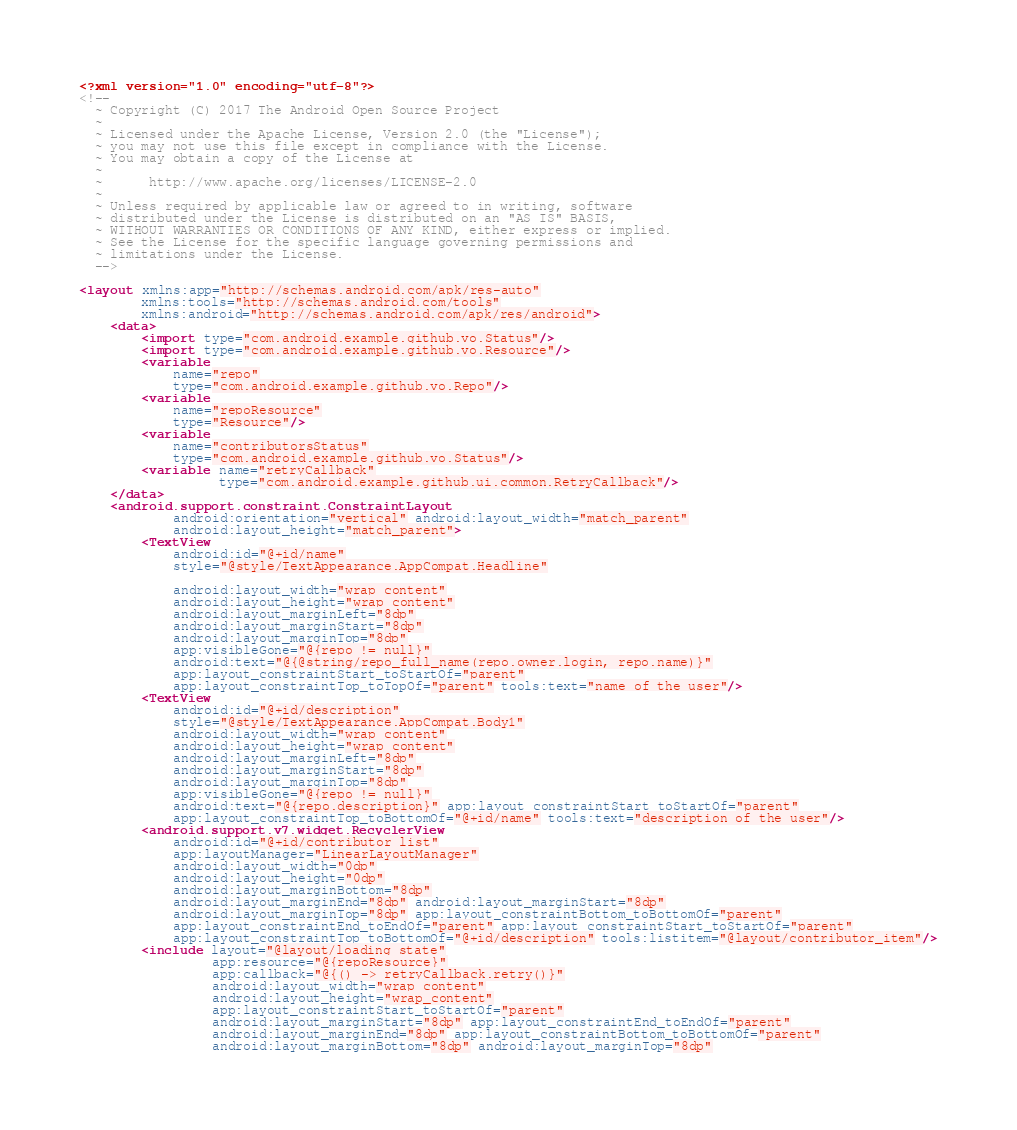Convert code to text. <code><loc_0><loc_0><loc_500><loc_500><_XML_><?xml version="1.0" encoding="utf-8"?>
<!--
  ~ Copyright (C) 2017 The Android Open Source Project
  ~
  ~ Licensed under the Apache License, Version 2.0 (the "License");
  ~ you may not use this file except in compliance with the License.
  ~ You may obtain a copy of the License at
  ~
  ~      http://www.apache.org/licenses/LICENSE-2.0
  ~
  ~ Unless required by applicable law or agreed to in writing, software
  ~ distributed under the License is distributed on an "AS IS" BASIS,
  ~ WITHOUT WARRANTIES OR CONDITIONS OF ANY KIND, either express or implied.
  ~ See the License for the specific language governing permissions and
  ~ limitations under the License.
  -->

<layout xmlns:app="http://schemas.android.com/apk/res-auto"
        xmlns:tools="http://schemas.android.com/tools"
        xmlns:android="http://schemas.android.com/apk/res/android">
    <data>
        <import type="com.android.example.github.vo.Status"/>
        <import type="com.android.example.github.vo.Resource"/>
        <variable
            name="repo"
            type="com.android.example.github.vo.Repo"/>
        <variable
            name="repoResource"
            type="Resource"/>
        <variable
            name="contributorsStatus"
            type="com.android.example.github.vo.Status"/>
        <variable name="retryCallback"
                  type="com.android.example.github.ui.common.RetryCallback"/>
    </data>
    <android.support.constraint.ConstraintLayout
            android:orientation="vertical" android:layout_width="match_parent"
            android:layout_height="match_parent">
        <TextView
            android:id="@+id/name"
            style="@style/TextAppearance.AppCompat.Headline"

            android:layout_width="wrap_content"
            android:layout_height="wrap_content"
            android:layout_marginLeft="8dp"
            android:layout_marginStart="8dp"
            android:layout_marginTop="8dp"
            app:visibleGone="@{repo != null}"
            android:text="@{@string/repo_full_name(repo.owner.login, repo.name)}"
            app:layout_constraintStart_toStartOf="parent"
            app:layout_constraintTop_toTopOf="parent" tools:text="name of the user"/>
        <TextView
            android:id="@+id/description"
            style="@style/TextAppearance.AppCompat.Body1"
            android:layout_width="wrap_content"
            android:layout_height="wrap_content"
            android:layout_marginLeft="8dp"
            android:layout_marginStart="8dp"
            android:layout_marginTop="8dp"
            app:visibleGone="@{repo != null}"
            android:text="@{repo.description}" app:layout_constraintStart_toStartOf="parent"
            app:layout_constraintTop_toBottomOf="@+id/name" tools:text="description of the user"/>
        <android.support.v7.widget.RecyclerView
            android:id="@+id/contributor_list"
            app:layoutManager="LinearLayoutManager"
            android:layout_width="0dp"
            android:layout_height="0dp"
            android:layout_marginBottom="8dp"
            android:layout_marginEnd="8dp" android:layout_marginStart="8dp"
            android:layout_marginTop="8dp" app:layout_constraintBottom_toBottomOf="parent"
            app:layout_constraintEnd_toEndOf="parent" app:layout_constraintStart_toStartOf="parent"
            app:layout_constraintTop_toBottomOf="@+id/description" tools:listitem="@layout/contributor_item"/>
        <include layout="@layout/loading_state"
                 app:resource="@{repoResource}"
                 app:callback="@{() -> retryCallback.retry()}"
                 android:layout_width="wrap_content"
                 android:layout_height="wrap_content"
                 app:layout_constraintStart_toStartOf="parent"
                 android:layout_marginStart="8dp" app:layout_constraintEnd_toEndOf="parent"
                 android:layout_marginEnd="8dp" app:layout_constraintBottom_toBottomOf="parent"
                 android:layout_marginBottom="8dp" android:layout_marginTop="8dp"</code> 